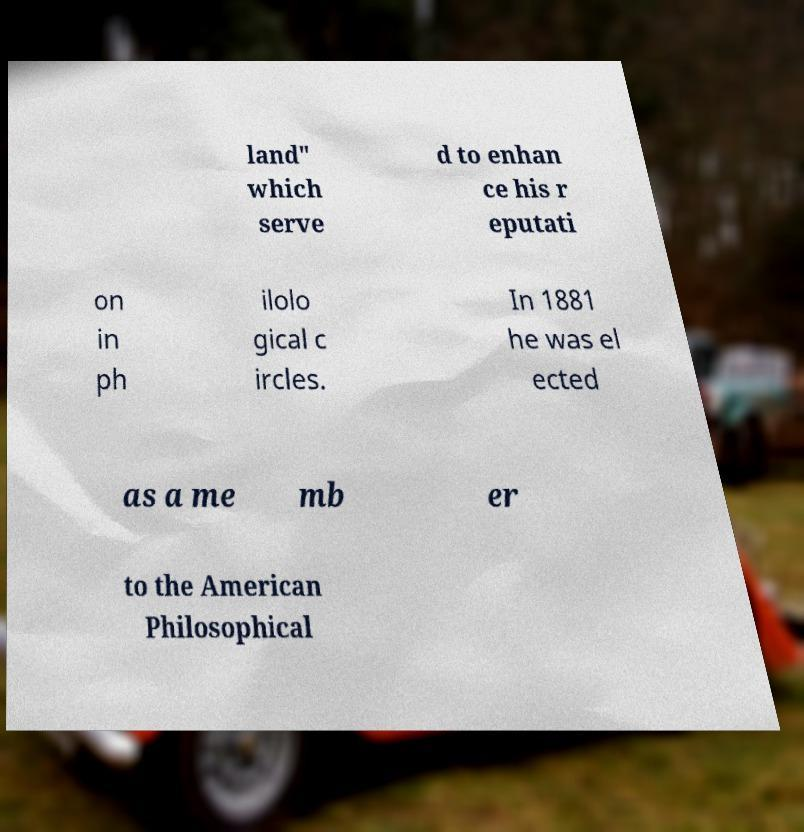For documentation purposes, I need the text within this image transcribed. Could you provide that? land" which serve d to enhan ce his r eputati on in ph ilolo gical c ircles. In 1881 he was el ected as a me mb er to the American Philosophical 